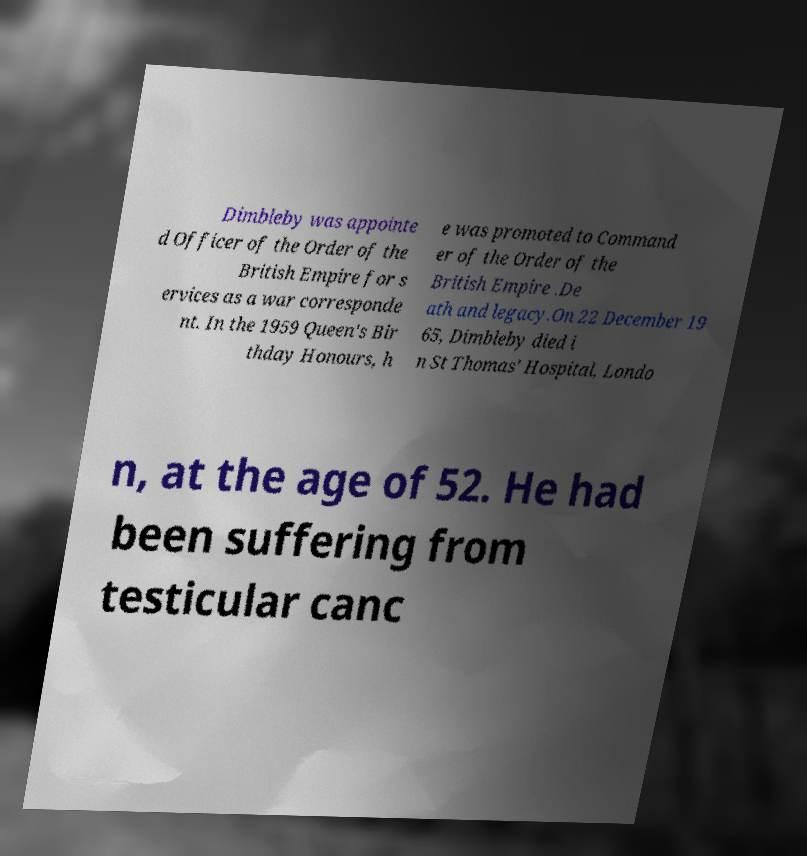Please read and relay the text visible in this image. What does it say? Dimbleby was appointe d Officer of the Order of the British Empire for s ervices as a war corresponde nt. In the 1959 Queen's Bir thday Honours, h e was promoted to Command er of the Order of the British Empire .De ath and legacy.On 22 December 19 65, Dimbleby died i n St Thomas' Hospital, Londo n, at the age of 52. He had been suffering from testicular canc 